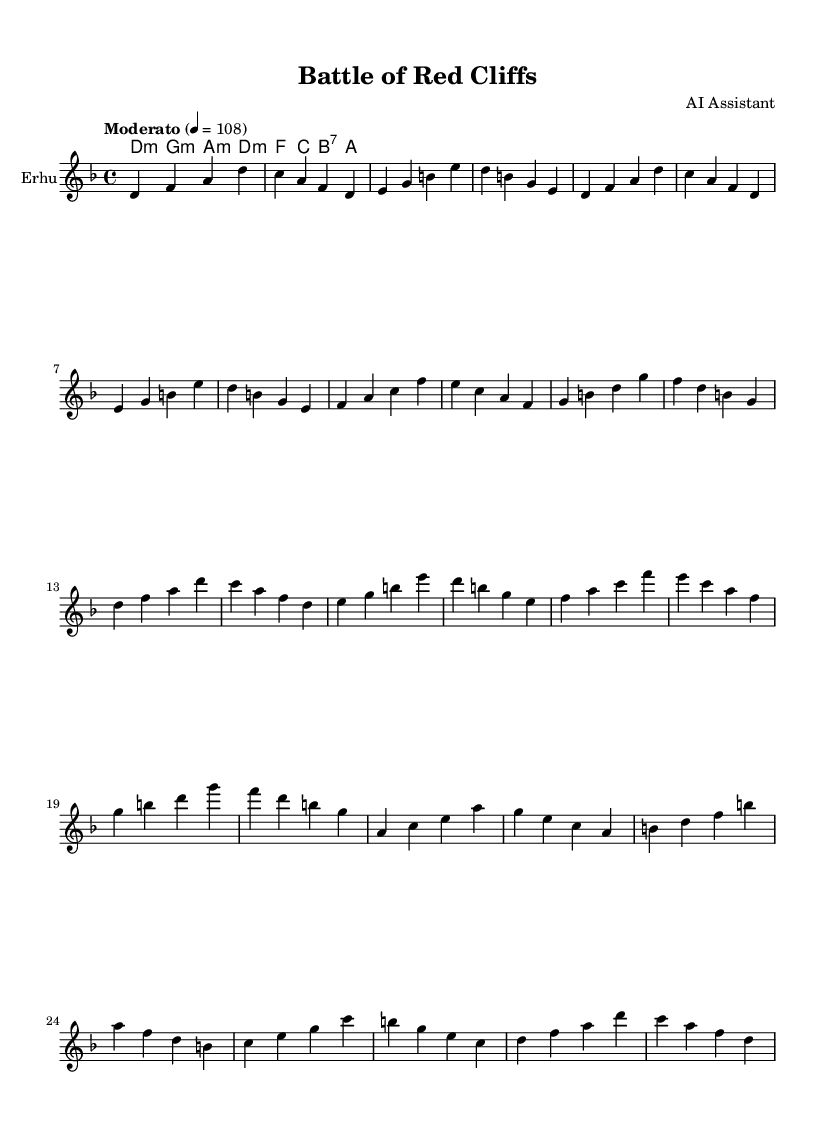What is the key signature of this music? The key signature is indicated as D minor. In the provided global settings of the music, the key is established at the start, and it is D minor which has one flat (B♭).
Answer: D minor What is the time signature of this music? The time signature is 4/4, which is explicitly noted in the global settings. This indicates that there are four beats per measure, and the quarter note gets one beat.
Answer: 4/4 What is the tempo marking for this music? The tempo marking is "Moderato" with a speed of 108 beats per minute. This is specified in the global settings and indicates a moderate pace.
Answer: Moderato How many measures are in the melody? By counting the segments in the melody section, there are a total of 16 measures. Each group of four beats equals one measure, and the melody written contains 16 distinct phrases.
Answer: 16 What is the primary theme depicted in the lyrics? The lyrics express the conflict and strategies during the Battle of Red Cliffs, which involved notable figures like Cao Cao, Zhou Yu, Liu Bei, and Sun Quan, portraying a significant historical event from the Three Kingdoms period.
Answer: Battle of Red Cliffs What instrument is indicated for the melody in this score? The instrument specified in the score for the melody is the Erhu, as noted in the staff settings. This string instrument is commonly used in Sichuan Opera.
Answer: Erhu 